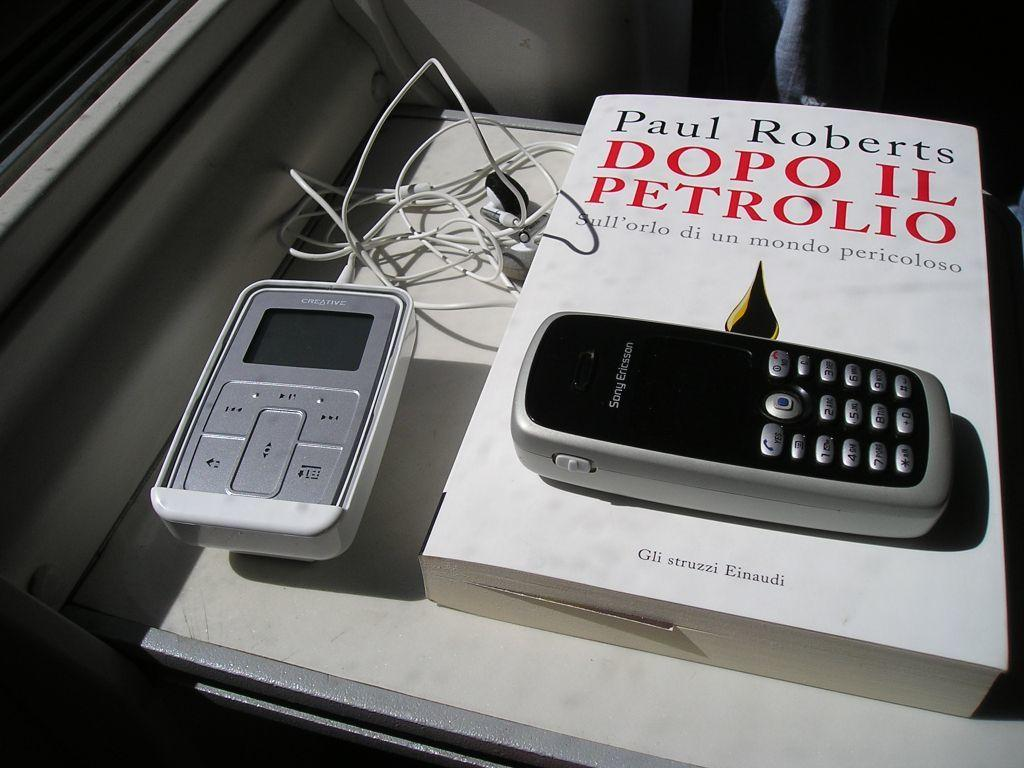<image>
Relay a brief, clear account of the picture shown. A cell phone sits on top of a book by Paul Roberts. 